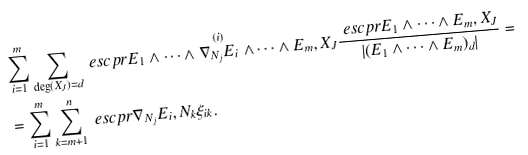Convert formula to latex. <formula><loc_0><loc_0><loc_500><loc_500>& \sum _ { i = 1 } ^ { m } \sum _ { \deg ( X _ { J } ) = d } \ e s c p r { E _ { 1 } \wedge \dots \wedge \stackrel { ( i ) } { \nabla _ { N _ { j } } E _ { i } } \wedge \dots \wedge E _ { m } , X _ { J } } \frac { \ e s c p r { E _ { 1 } \wedge \dots \wedge E _ { m } , X _ { J } } } { | ( E _ { 1 } \wedge \dots \wedge E _ { m } ) _ { d } | } = \\ & = \sum _ { i = 1 } ^ { m } \sum _ { k = m + 1 } ^ { n } \ e s c p r { \nabla _ { N _ { j } } E _ { i } , N _ { k } } \xi _ { i k } .</formula> 